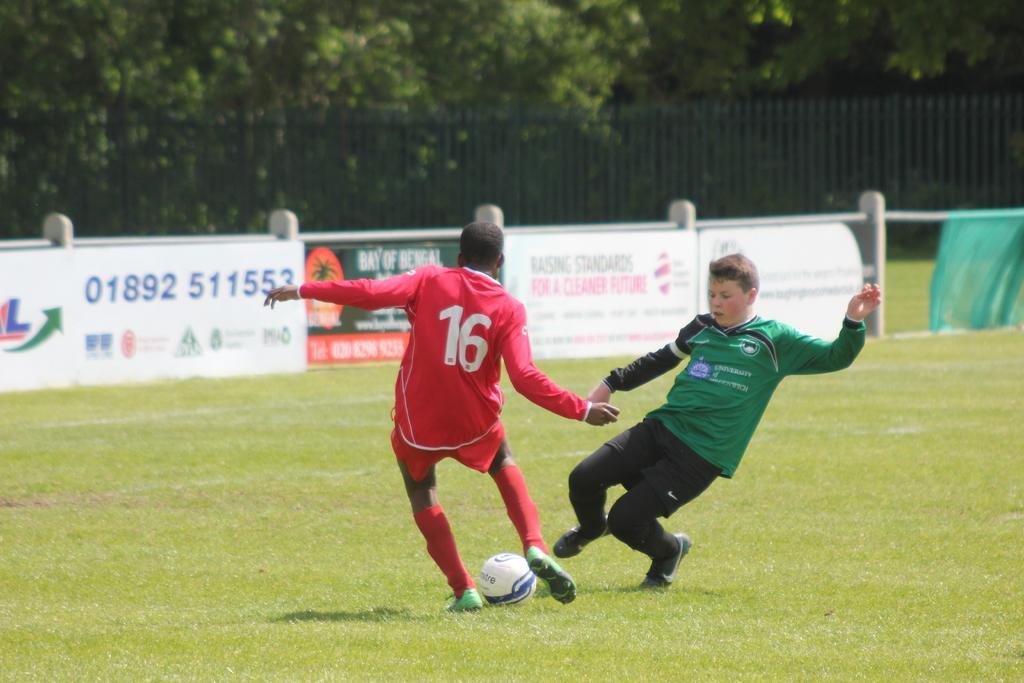Can you describe this image briefly? In this image, there is an outside view. There are two persons wearing clothes and playing a football. In the background, there is a fencing and some trees. 